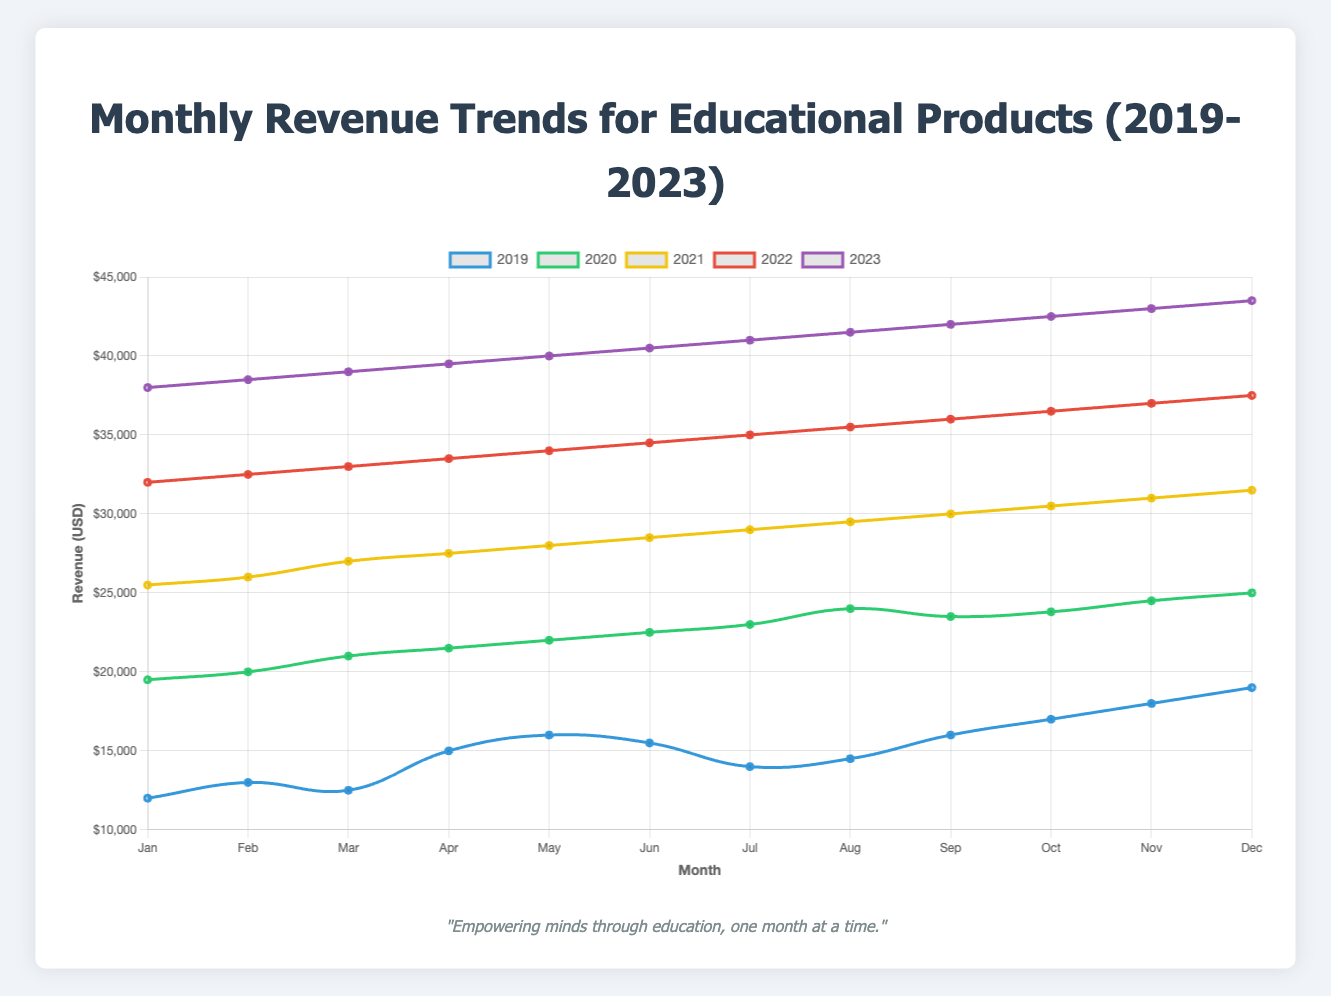Which year had the highest revenue in December? Look at the data for December across each year and identify the highest value. The highest revenue in December is $43,500 in 2023.
Answer: 2023 How much did the revenue increase from January to December in 2021? Identify the revenue values for January and December of 2021. Subtract the January revenue from the December revenue: $31,500 - $25,500 = $6,000.
Answer: $6,000 What is the average monthly revenue for 2020? Add each month's revenue for 2020 and divide by 12: ($19,500 + $20,000 + $21,000 + $21,500 + $22,000 + $22,500 + $23,000 + $24,000 + $23,500 + $23,800 + $24,500 + $25,000) / 12 = $22,158.33.
Answer: $22,158.33 Which month in 2022 showed the highest revenue growth compared to the previous month? Check the month-to-month differences in 2022: $33,500 - $33,000 = $500 (April); $34,000 - $33,500 = $1,000 (April to May); continue this process for each month. The highest increase is from January to February ($32,500 - $32,000 = $500). The largest growth is from May to June ($34,500 - $34,000 = $4,500).
Answer: May What is the total revenue for the year 2019? Summing the monthly data for the year 2019: $12,000 + $13,000 + $12,500 + $15,000 + $16,000 + $15,500 + $14,000 + $14,500 + $16,000 + $17,000 + $18,000 + $19,000 = $182,500.
Answer: $182,500 How does the revenue in June 2023 compare to the revenue in June 2019? Refer to the values for June in both years. Revenue in June 2023 is $40,500 while in June 2019 it was $15,500. Calculate the difference: $40,500 - $15,500 = $25,000.
Answer: $25,000 What is the general trend of the revenue from 2019 to 2023? Observe the overall pattern in the data from 2019 to 2023. Revenues generally increase each year from 2019 to 2023, showing a continuous upward trend.
Answer: Upward Which year had the most consistent monthly revenue, based on the visual trend line? Visually inspect the lines for each year: 2019 shows more fluctuation, while 2020 onwards indicates more stable increases. Among these, 2022 and 2023 have very little fluctuation each month and grow consistently.
Answer: 2023 